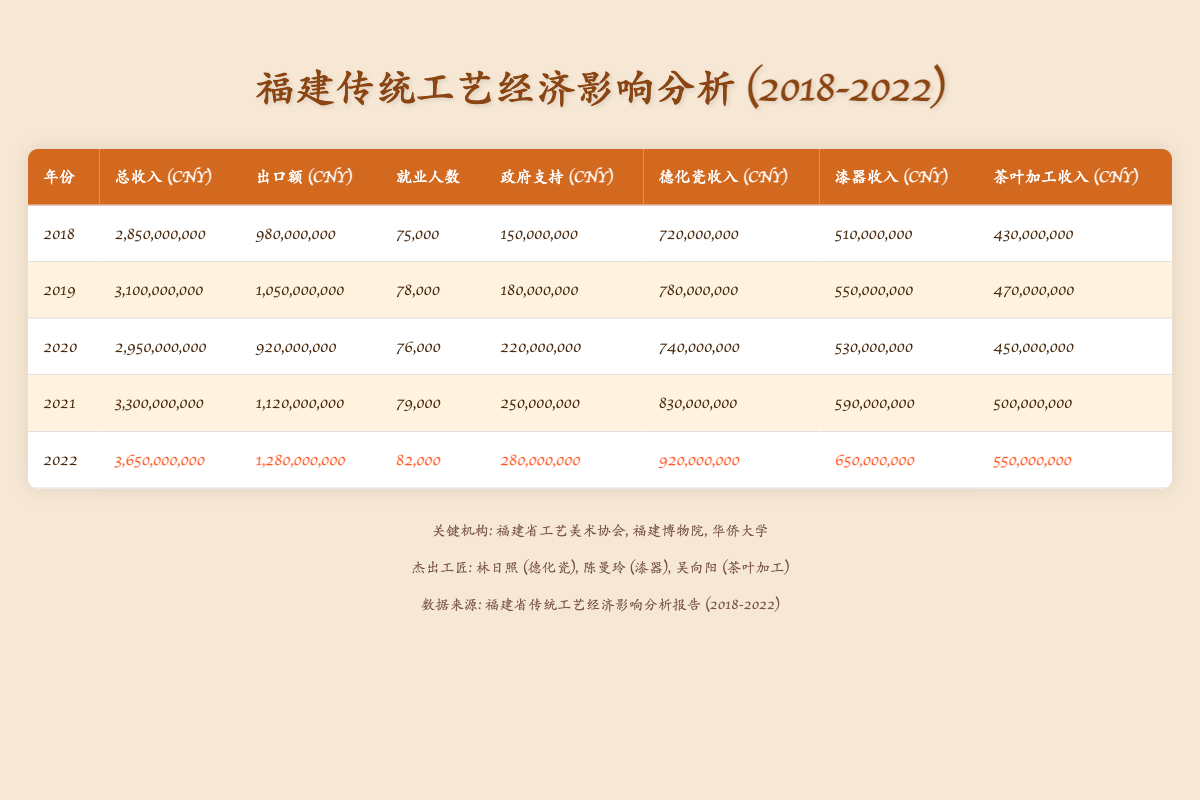What was the total revenue in 2022? According to the table, the value in the "总收入 (CNY)" column for the year 2022 is listed as 3,650,000,000.
Answer: 3,650,000,000 Which year had the highest export value? By comparing the "出口额 (CNY)" values across all years, the highest value appears in 2022 at 1,280,000,000.
Answer: 2022 What is the total employment in the traditional crafts industry from 2018 to 2022? To find the total employment, we sum the employment numbers: 75,000 + 78,000 + 76,000 + 79,000 + 82,000 = 390,000.
Answer: 390,000 Was the government support in 2020 greater than in 2019? The government support for 2020 is 220,000,000 and for 2019 is 180,000,000. Since 220,000,000 > 180,000,000, the statement is true.
Answer: Yes How much did Dehua porcelain revenue increase from 2018 to 2022? The revenue for Dehua porcelain in 2018 is 720,000,000 and in 2022 is 920,000,000. The increase can be calculated as 920,000,000 - 720,000,000 = 200,000,000.
Answer: 200,000,000 What was the average government support over the five years? The total government support over five years is calculated as: 150,000,000 + 180,000,000 + 220,000,000 + 250,000,000 + 280,000,000 = 1,080,000,000. To find the average, divide by 5: 1,080,000,000 / 5 = 216,000,000.
Answer: 216,000,000 Which crafts category had the highest revenue in 2021? Looking at the categories for the year 2021, Dehua porcelain earned 830,000,000, Lacquerware earned 590,000,000, and Tea Processing earned 500,000,000. The highest revenue is thus from Dehua porcelain at 830,000,000.
Answer: Dehua porcelain Is the total revenue in 2019 greater than that in 2020? The total revenue in 2019 is 3,100,000,000, and in 2020 it is 2,950,000,000. Since 3,100,000,000 > 2,950,000,000, the answer is yes.
Answer: Yes 